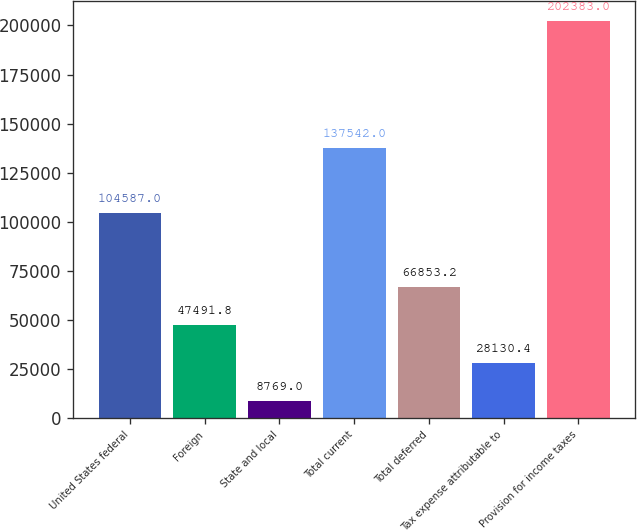<chart> <loc_0><loc_0><loc_500><loc_500><bar_chart><fcel>United States federal<fcel>Foreign<fcel>State and local<fcel>Total current<fcel>Total deferred<fcel>Tax expense attributable to<fcel>Provision for income taxes<nl><fcel>104587<fcel>47491.8<fcel>8769<fcel>137542<fcel>66853.2<fcel>28130.4<fcel>202383<nl></chart> 